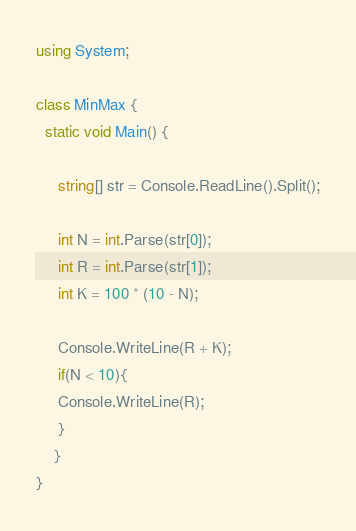Convert code to text. <code><loc_0><loc_0><loc_500><loc_500><_C#_>using System;

class MinMax {  
  static void Main() {  
    
     string[] str = Console.ReadLine().Split();
     
     int N = int.Parse(str[0]);
     int R = int.Parse(str[1]);
     int K = 100 * (10 - N); 

     Console.WriteLine(R + K);
     if(N < 10){
     Console.WriteLine(R);
     }
    }
}  </code> 